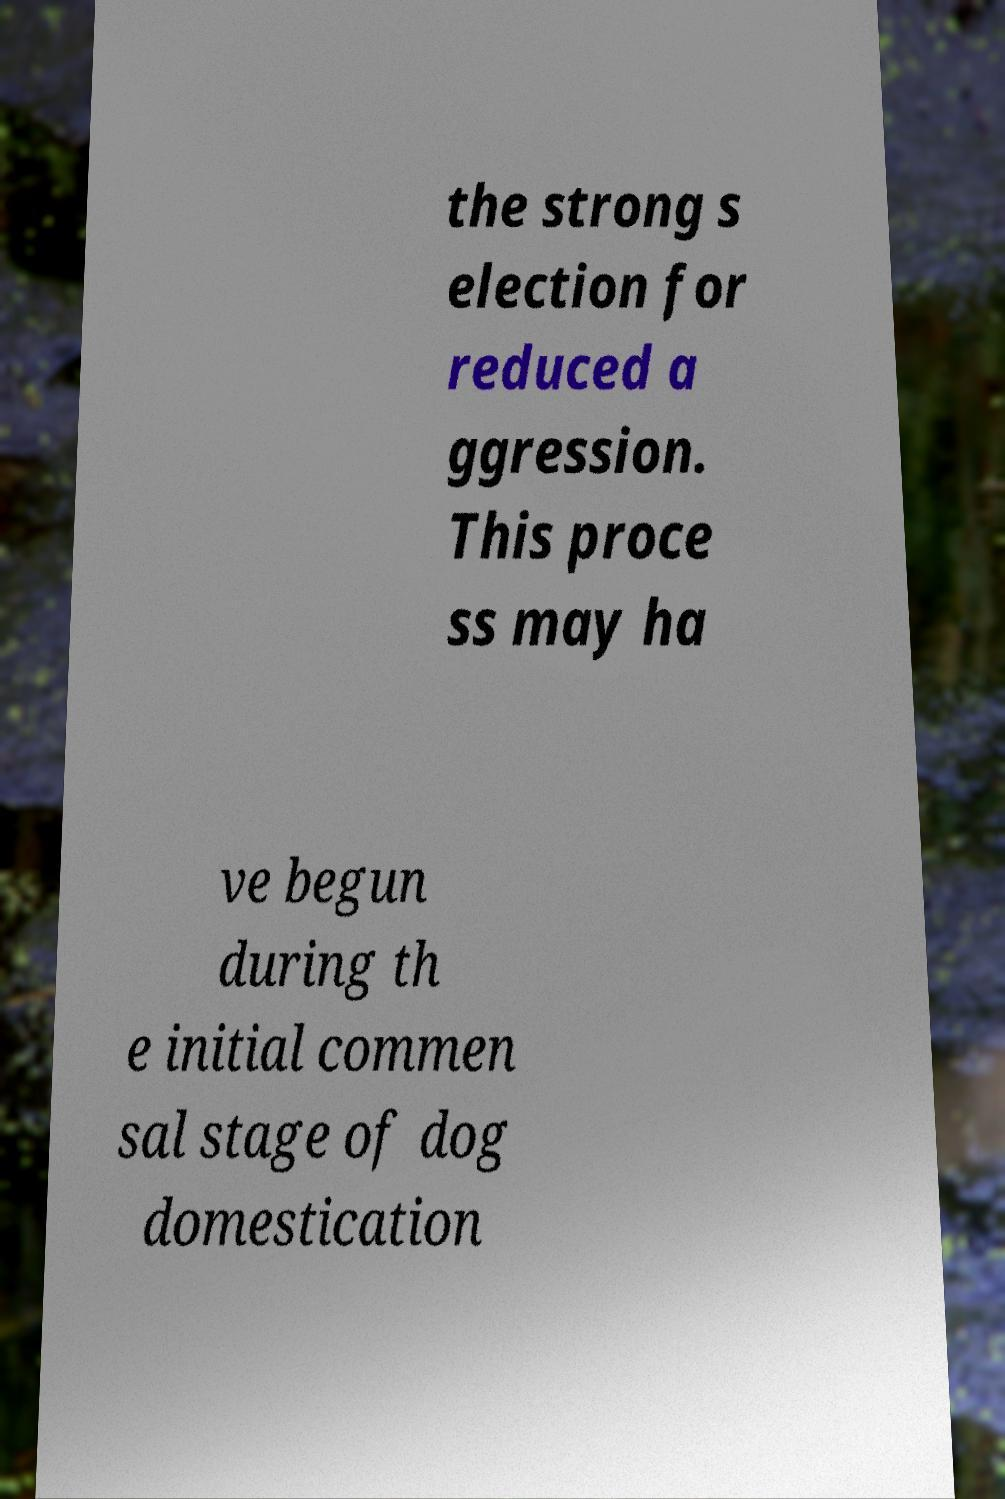Could you extract and type out the text from this image? the strong s election for reduced a ggression. This proce ss may ha ve begun during th e initial commen sal stage of dog domestication 